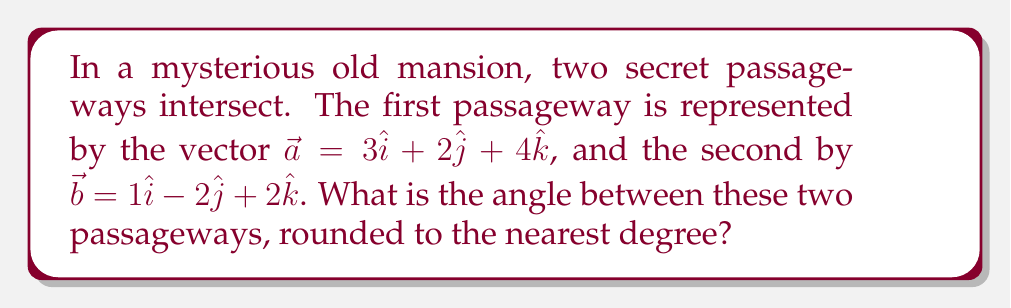Provide a solution to this math problem. To find the angle between two vectors in 3D space, we can use the dot product formula:

$$\cos \theta = \frac{\vec{a} \cdot \vec{b}}{|\vec{a}||\vec{b}|}$$

Step 1: Calculate the dot product $\vec{a} \cdot \vec{b}$
$$\vec{a} \cdot \vec{b} = (3)(1) + (2)(-2) + (4)(2) = 3 - 4 + 8 = 7$$

Step 2: Calculate the magnitudes of $\vec{a}$ and $\vec{b}$
$$|\vec{a}| = \sqrt{3^2 + 2^2 + 4^2} = \sqrt{9 + 4 + 16} = \sqrt{29}$$
$$|\vec{b}| = \sqrt{1^2 + (-2)^2 + 2^2} = \sqrt{1 + 4 + 4} = 3$$

Step 3: Substitute into the formula
$$\cos \theta = \frac{7}{\sqrt{29} \cdot 3}$$

Step 4: Calculate $\theta$ using inverse cosine
$$\theta = \arccos\left(\frac{7}{\sqrt{29} \cdot 3}\right)$$

Step 5: Convert to degrees and round to the nearest degree
$$\theta \approx 66°$$
Answer: 66° 